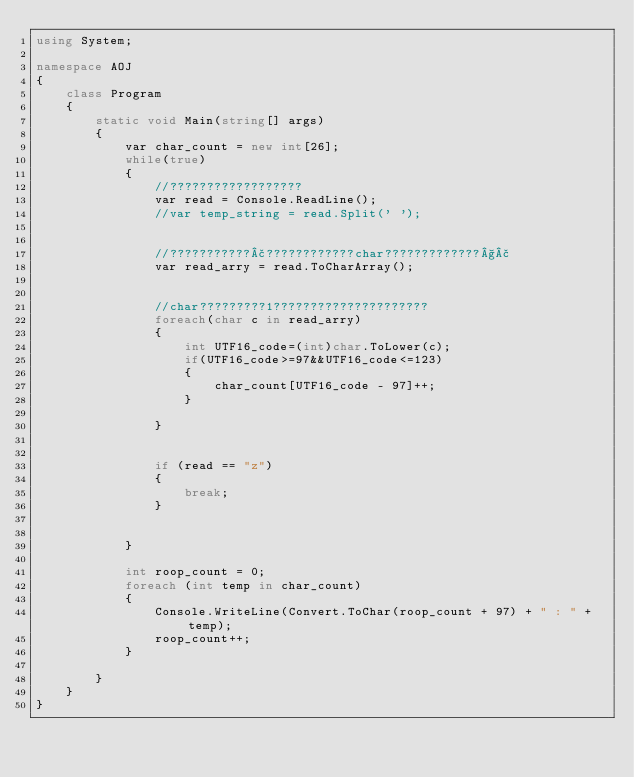Convert code to text. <code><loc_0><loc_0><loc_500><loc_500><_C#_>using System;

namespace AOJ
{
    class Program
    {
        static void Main(string[] args)
        {
            var char_count = new int[26];
            while(true)
            {
                //??????????????????
                var read = Console.ReadLine();
                //var temp_string = read.Split(' ');


                //???????????£????????????char?????????????§£
                var read_arry = read.ToCharArray();


                //char?????????1?????????????????????
                foreach(char c in read_arry)
                {
                    int UTF16_code=(int)char.ToLower(c);
                    if(UTF16_code>=97&&UTF16_code<=123)
                    {
                        char_count[UTF16_code - 97]++;
                    }

                }


                if (read == "z")
                {
                    break;
                }

                
            }

            int roop_count = 0;
            foreach (int temp in char_count)
            {
                Console.WriteLine(Convert.ToChar(roop_count + 97) + " : " + temp);
                roop_count++;
            }
            
        }
    }
}</code> 